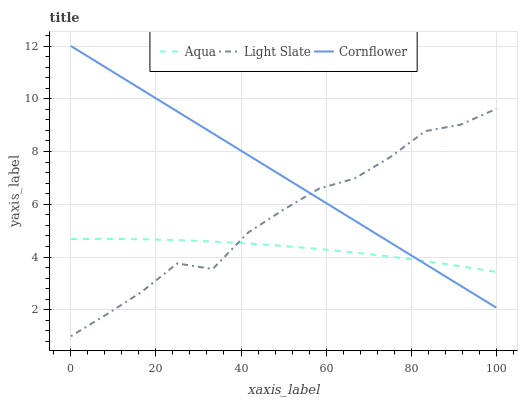Does Aqua have the minimum area under the curve?
Answer yes or no. Yes. Does Cornflower have the maximum area under the curve?
Answer yes or no. Yes. Does Cornflower have the minimum area under the curve?
Answer yes or no. No. Does Aqua have the maximum area under the curve?
Answer yes or no. No. Is Cornflower the smoothest?
Answer yes or no. Yes. Is Light Slate the roughest?
Answer yes or no. Yes. Is Aqua the smoothest?
Answer yes or no. No. Is Aqua the roughest?
Answer yes or no. No. Does Light Slate have the lowest value?
Answer yes or no. Yes. Does Cornflower have the lowest value?
Answer yes or no. No. Does Cornflower have the highest value?
Answer yes or no. Yes. Does Aqua have the highest value?
Answer yes or no. No. Does Cornflower intersect Light Slate?
Answer yes or no. Yes. Is Cornflower less than Light Slate?
Answer yes or no. No. Is Cornflower greater than Light Slate?
Answer yes or no. No. 